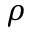Convert formula to latex. <formula><loc_0><loc_0><loc_500><loc_500>\rho</formula> 